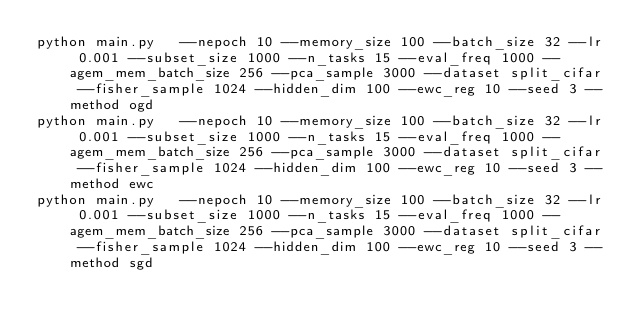<code> <loc_0><loc_0><loc_500><loc_500><_Bash_>python main.py   --nepoch 10 --memory_size 100 --batch_size 32 --lr 0.001 --subset_size 1000 --n_tasks 15 --eval_freq 1000 --agem_mem_batch_size 256 --pca_sample 3000 --dataset split_cifar --fisher_sample 1024 --hidden_dim 100 --ewc_reg 10 --seed 3 --method ogd
python main.py   --nepoch 10 --memory_size 100 --batch_size 32 --lr 0.001 --subset_size 1000 --n_tasks 15 --eval_freq 1000 --agem_mem_batch_size 256 --pca_sample 3000 --dataset split_cifar --fisher_sample 1024 --hidden_dim 100 --ewc_reg 10 --seed 3 --method ewc
python main.py   --nepoch 10 --memory_size 100 --batch_size 32 --lr 0.001 --subset_size 1000 --n_tasks 15 --eval_freq 1000 --agem_mem_batch_size 256 --pca_sample 3000 --dataset split_cifar --fisher_sample 1024 --hidden_dim 100 --ewc_reg 10 --seed 3 --method sgd</code> 